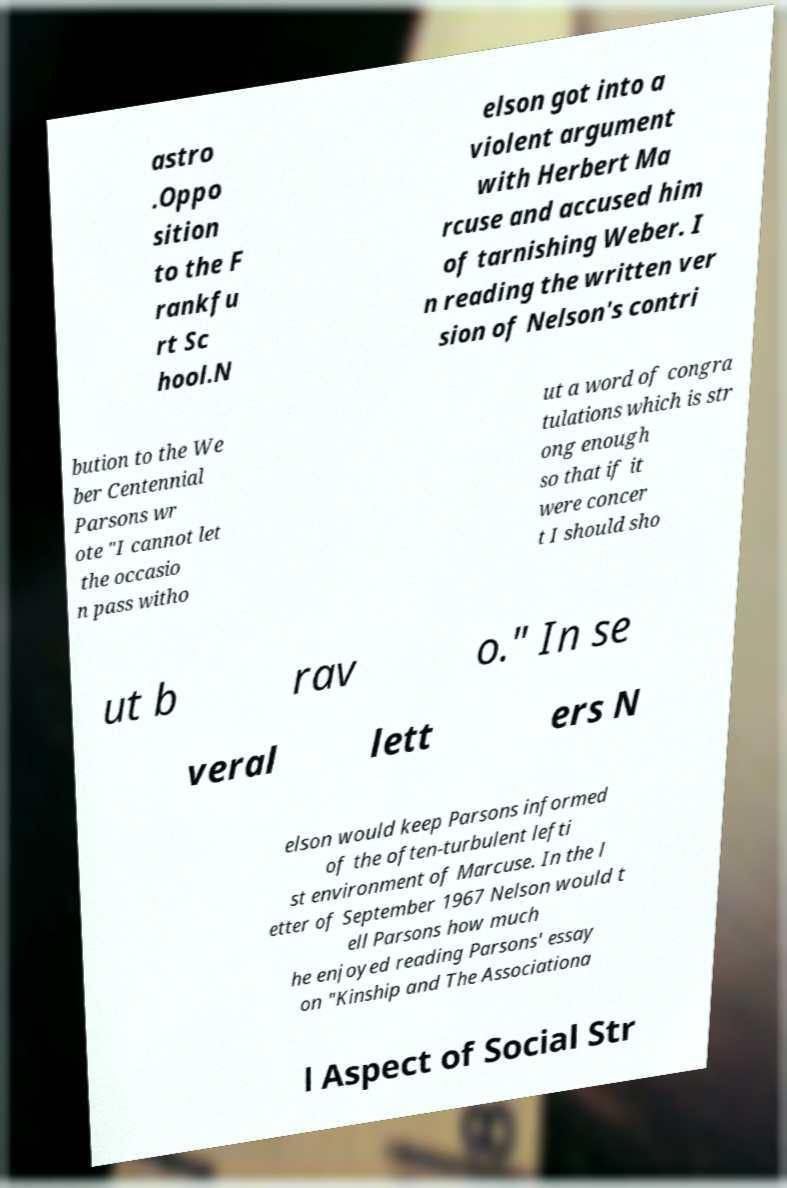Could you extract and type out the text from this image? astro .Oppo sition to the F rankfu rt Sc hool.N elson got into a violent argument with Herbert Ma rcuse and accused him of tarnishing Weber. I n reading the written ver sion of Nelson's contri bution to the We ber Centennial Parsons wr ote "I cannot let the occasio n pass witho ut a word of congra tulations which is str ong enough so that if it were concer t I should sho ut b rav o." In se veral lett ers N elson would keep Parsons informed of the often-turbulent lefti st environment of Marcuse. In the l etter of September 1967 Nelson would t ell Parsons how much he enjoyed reading Parsons' essay on "Kinship and The Associationa l Aspect of Social Str 